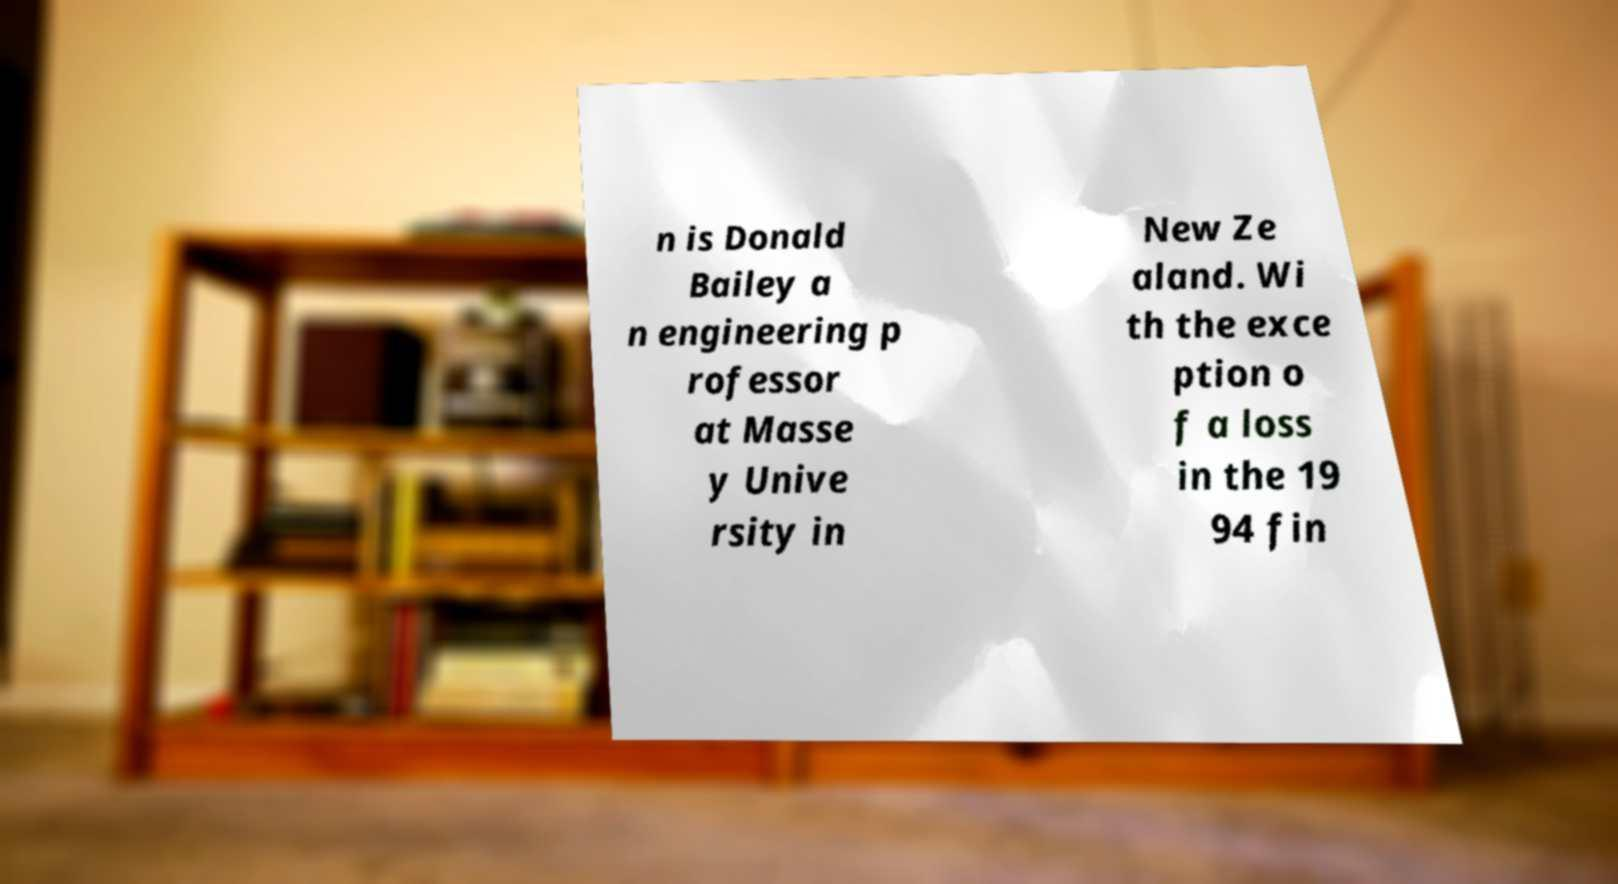For documentation purposes, I need the text within this image transcribed. Could you provide that? n is Donald Bailey a n engineering p rofessor at Masse y Unive rsity in New Ze aland. Wi th the exce ption o f a loss in the 19 94 fin 